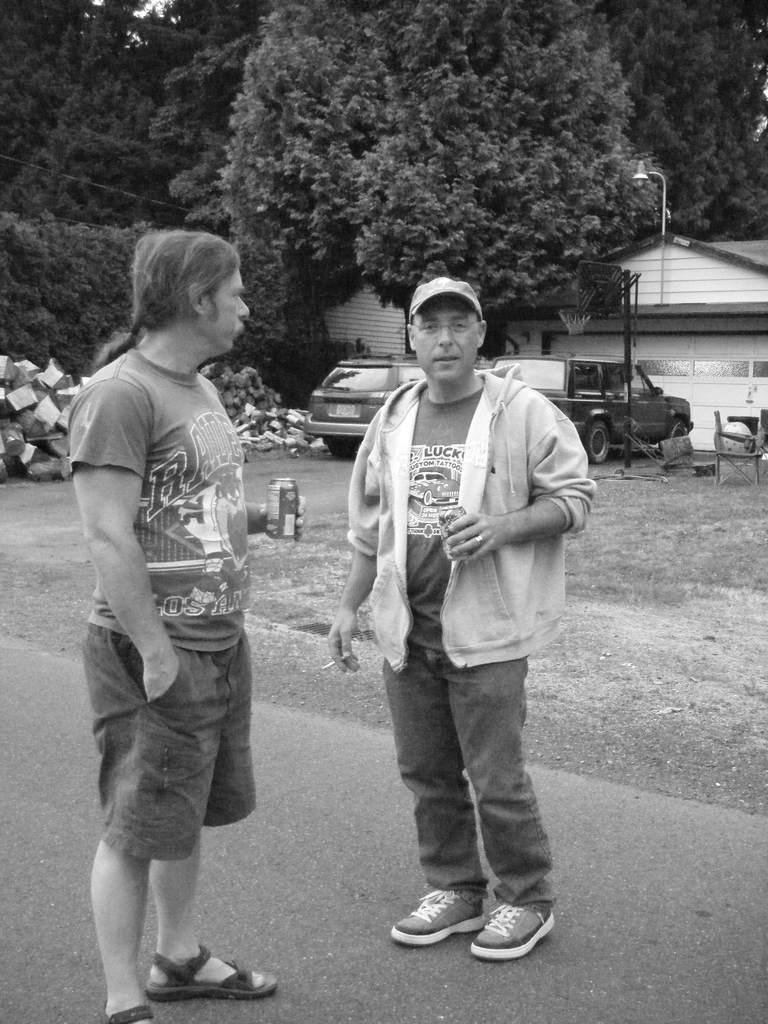What is the color scheme of the image? The image is black and white. How many people are present in the image? There are two persons standing on the road. What can be seen in the background of the image? There are trees and a house in the background of the image. What type of vehicles are visible in the image? There are cars in the image. Where is the grandmother sitting in the image? There is no grandmother present in the image. Can you tell me how many ducks are walking on the road in the image? There are no ducks present in the image; it features two persons standing on the road. 